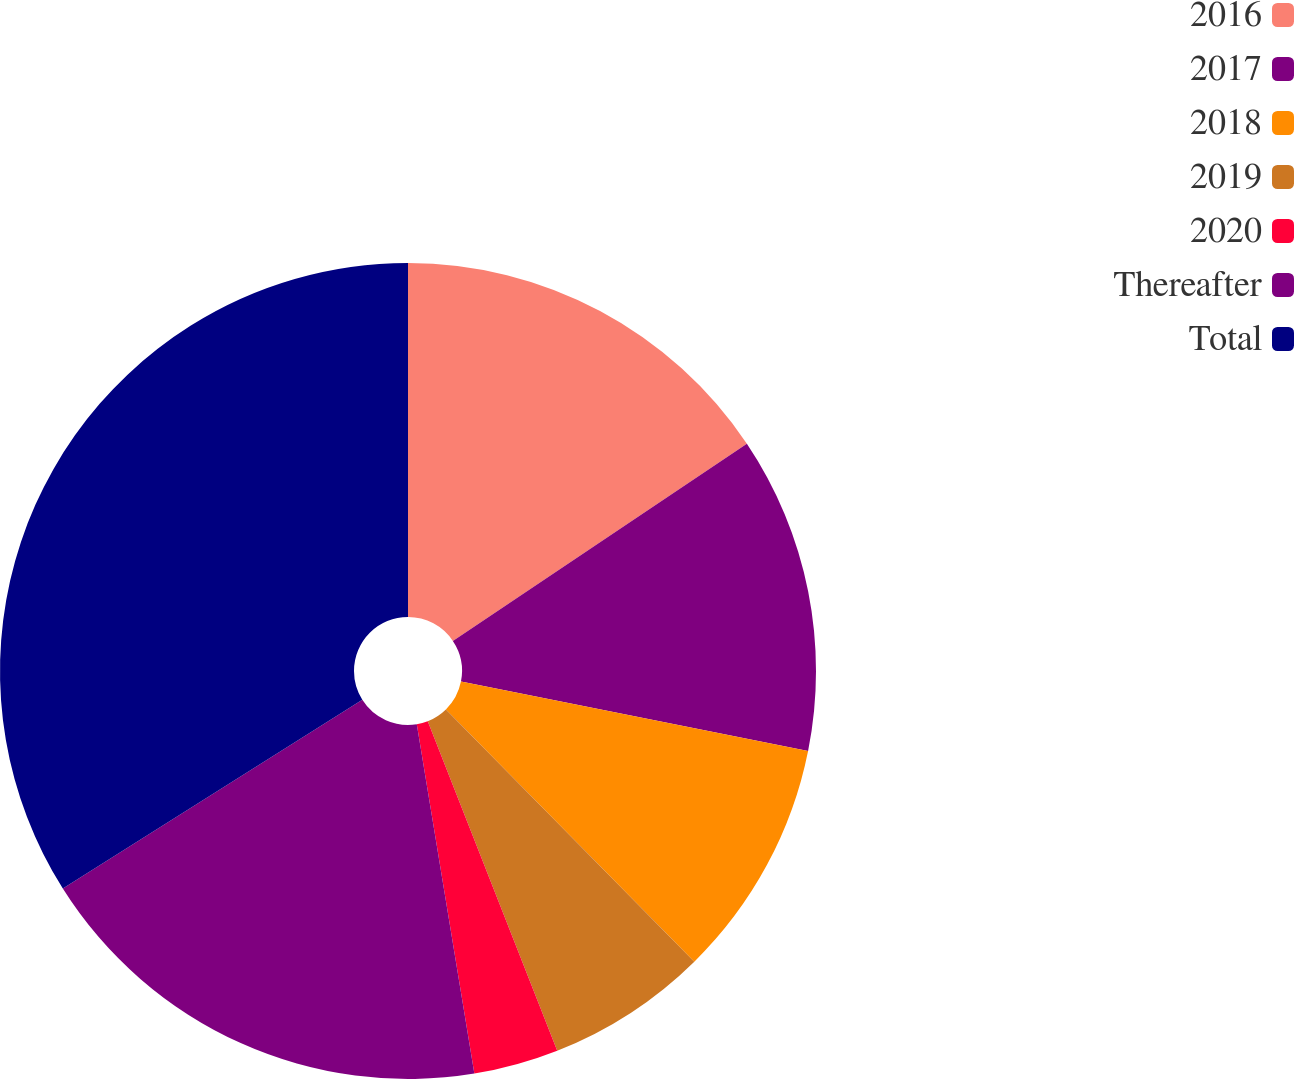Convert chart. <chart><loc_0><loc_0><loc_500><loc_500><pie_chart><fcel>2016<fcel>2017<fcel>2018<fcel>2019<fcel>2020<fcel>Thereafter<fcel>Total<nl><fcel>15.6%<fcel>12.54%<fcel>9.48%<fcel>6.42%<fcel>3.36%<fcel>18.65%<fcel>33.95%<nl></chart> 